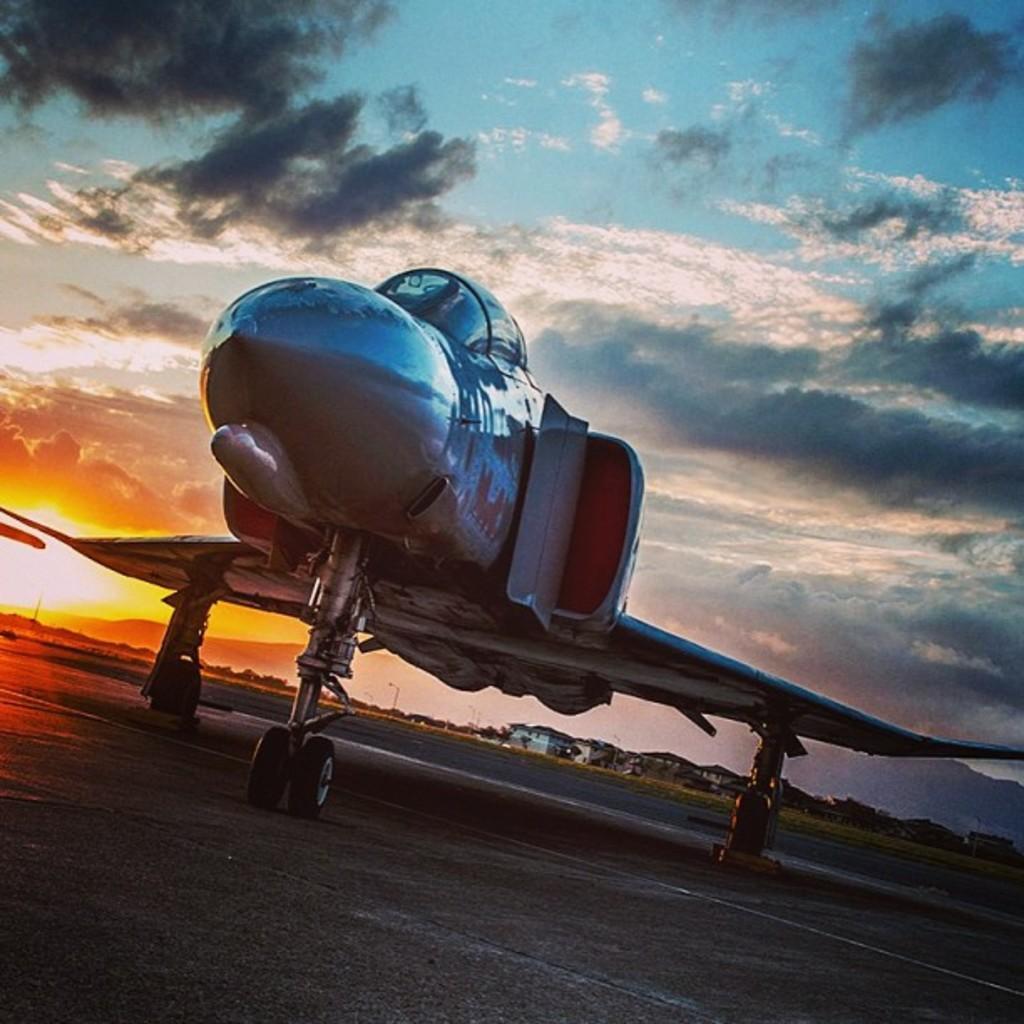How would you summarize this image in a sentence or two? In the picture we can see a plane which is parked on the path and far away from it, we can see some houses, trees, poles with lights and sky with clouds and sun. 